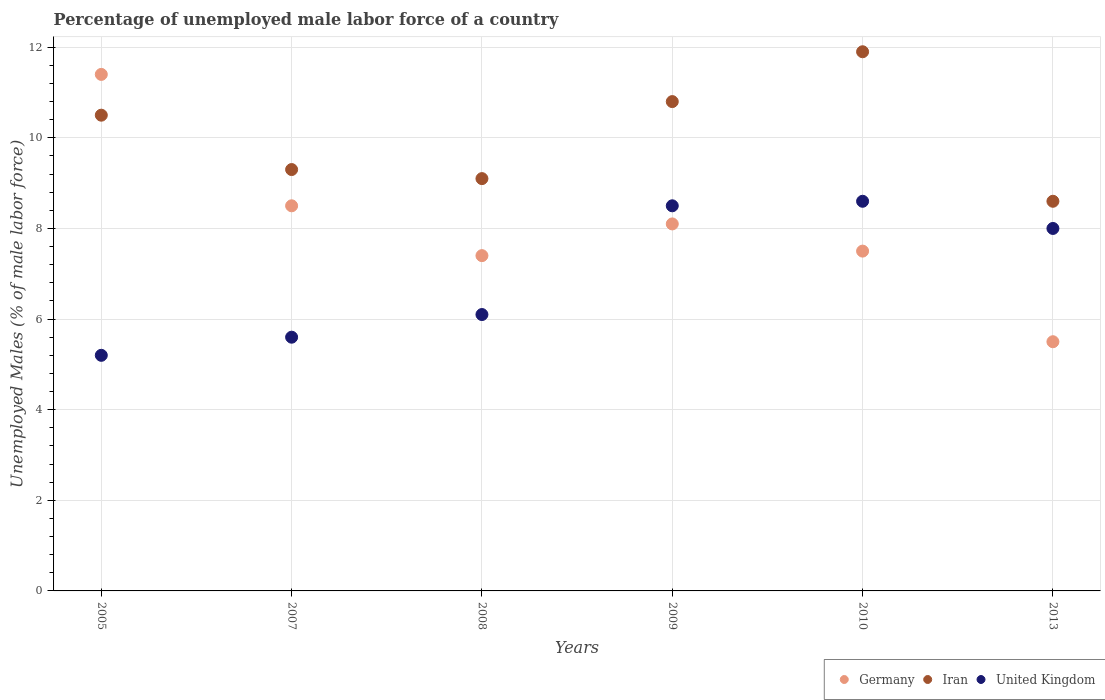Is the number of dotlines equal to the number of legend labels?
Give a very brief answer. Yes. What is the percentage of unemployed male labor force in Iran in 2010?
Make the answer very short. 11.9. Across all years, what is the maximum percentage of unemployed male labor force in Germany?
Your answer should be compact. 11.4. What is the total percentage of unemployed male labor force in Germany in the graph?
Your response must be concise. 48.4. What is the difference between the percentage of unemployed male labor force in United Kingdom in 2005 and that in 2010?
Ensure brevity in your answer.  -3.4. What is the difference between the percentage of unemployed male labor force in Iran in 2005 and the percentage of unemployed male labor force in Germany in 2009?
Keep it short and to the point. 2.4. What is the average percentage of unemployed male labor force in United Kingdom per year?
Give a very brief answer. 7. In the year 2005, what is the difference between the percentage of unemployed male labor force in United Kingdom and percentage of unemployed male labor force in Iran?
Make the answer very short. -5.3. What is the ratio of the percentage of unemployed male labor force in Iran in 2007 to that in 2008?
Ensure brevity in your answer.  1.02. Is the percentage of unemployed male labor force in Iran in 2005 less than that in 2013?
Offer a terse response. No. Is the difference between the percentage of unemployed male labor force in United Kingdom in 2005 and 2009 greater than the difference between the percentage of unemployed male labor force in Iran in 2005 and 2009?
Your answer should be compact. No. What is the difference between the highest and the second highest percentage of unemployed male labor force in Iran?
Your response must be concise. 1.1. What is the difference between the highest and the lowest percentage of unemployed male labor force in United Kingdom?
Keep it short and to the point. 3.4. Is the sum of the percentage of unemployed male labor force in Iran in 2007 and 2013 greater than the maximum percentage of unemployed male labor force in Germany across all years?
Your answer should be very brief. Yes. Is the percentage of unemployed male labor force in United Kingdom strictly greater than the percentage of unemployed male labor force in Germany over the years?
Make the answer very short. No. Is the percentage of unemployed male labor force in United Kingdom strictly less than the percentage of unemployed male labor force in Iran over the years?
Your answer should be very brief. Yes. How many dotlines are there?
Your answer should be very brief. 3. How many legend labels are there?
Give a very brief answer. 3. What is the title of the graph?
Offer a terse response. Percentage of unemployed male labor force of a country. Does "Korea (Republic)" appear as one of the legend labels in the graph?
Ensure brevity in your answer.  No. What is the label or title of the Y-axis?
Ensure brevity in your answer.  Unemployed Males (% of male labor force). What is the Unemployed Males (% of male labor force) of Germany in 2005?
Your answer should be very brief. 11.4. What is the Unemployed Males (% of male labor force) in Iran in 2005?
Your answer should be compact. 10.5. What is the Unemployed Males (% of male labor force) in United Kingdom in 2005?
Your answer should be compact. 5.2. What is the Unemployed Males (% of male labor force) of Germany in 2007?
Give a very brief answer. 8.5. What is the Unemployed Males (% of male labor force) of Iran in 2007?
Ensure brevity in your answer.  9.3. What is the Unemployed Males (% of male labor force) of United Kingdom in 2007?
Ensure brevity in your answer.  5.6. What is the Unemployed Males (% of male labor force) of Germany in 2008?
Give a very brief answer. 7.4. What is the Unemployed Males (% of male labor force) of Iran in 2008?
Offer a very short reply. 9.1. What is the Unemployed Males (% of male labor force) in United Kingdom in 2008?
Give a very brief answer. 6.1. What is the Unemployed Males (% of male labor force) of Germany in 2009?
Provide a short and direct response. 8.1. What is the Unemployed Males (% of male labor force) in Iran in 2009?
Give a very brief answer. 10.8. What is the Unemployed Males (% of male labor force) in Germany in 2010?
Give a very brief answer. 7.5. What is the Unemployed Males (% of male labor force) of Iran in 2010?
Provide a succinct answer. 11.9. What is the Unemployed Males (% of male labor force) in United Kingdom in 2010?
Provide a short and direct response. 8.6. What is the Unemployed Males (% of male labor force) in Germany in 2013?
Provide a short and direct response. 5.5. What is the Unemployed Males (% of male labor force) of Iran in 2013?
Your answer should be very brief. 8.6. What is the Unemployed Males (% of male labor force) in United Kingdom in 2013?
Your answer should be compact. 8. Across all years, what is the maximum Unemployed Males (% of male labor force) in Germany?
Your response must be concise. 11.4. Across all years, what is the maximum Unemployed Males (% of male labor force) of Iran?
Offer a very short reply. 11.9. Across all years, what is the maximum Unemployed Males (% of male labor force) of United Kingdom?
Ensure brevity in your answer.  8.6. Across all years, what is the minimum Unemployed Males (% of male labor force) of Germany?
Offer a very short reply. 5.5. Across all years, what is the minimum Unemployed Males (% of male labor force) in Iran?
Provide a short and direct response. 8.6. Across all years, what is the minimum Unemployed Males (% of male labor force) in United Kingdom?
Ensure brevity in your answer.  5.2. What is the total Unemployed Males (% of male labor force) in Germany in the graph?
Your response must be concise. 48.4. What is the total Unemployed Males (% of male labor force) of Iran in the graph?
Provide a succinct answer. 60.2. What is the total Unemployed Males (% of male labor force) in United Kingdom in the graph?
Provide a short and direct response. 42. What is the difference between the Unemployed Males (% of male labor force) of Germany in 2005 and that in 2007?
Offer a very short reply. 2.9. What is the difference between the Unemployed Males (% of male labor force) of Iran in 2005 and that in 2007?
Keep it short and to the point. 1.2. What is the difference between the Unemployed Males (% of male labor force) in United Kingdom in 2005 and that in 2007?
Your answer should be very brief. -0.4. What is the difference between the Unemployed Males (% of male labor force) of United Kingdom in 2005 and that in 2008?
Offer a very short reply. -0.9. What is the difference between the Unemployed Males (% of male labor force) in Iran in 2005 and that in 2009?
Offer a very short reply. -0.3. What is the difference between the Unemployed Males (% of male labor force) in Iran in 2005 and that in 2010?
Provide a succinct answer. -1.4. What is the difference between the Unemployed Males (% of male labor force) in Germany in 2005 and that in 2013?
Your answer should be compact. 5.9. What is the difference between the Unemployed Males (% of male labor force) of Iran in 2007 and that in 2008?
Your response must be concise. 0.2. What is the difference between the Unemployed Males (% of male labor force) in Germany in 2007 and that in 2009?
Keep it short and to the point. 0.4. What is the difference between the Unemployed Males (% of male labor force) in Iran in 2007 and that in 2009?
Make the answer very short. -1.5. What is the difference between the Unemployed Males (% of male labor force) in United Kingdom in 2007 and that in 2010?
Your response must be concise. -3. What is the difference between the Unemployed Males (% of male labor force) in Iran in 2007 and that in 2013?
Keep it short and to the point. 0.7. What is the difference between the Unemployed Males (% of male labor force) of United Kingdom in 2007 and that in 2013?
Your response must be concise. -2.4. What is the difference between the Unemployed Males (% of male labor force) in Germany in 2008 and that in 2009?
Give a very brief answer. -0.7. What is the difference between the Unemployed Males (% of male labor force) in United Kingdom in 2008 and that in 2009?
Keep it short and to the point. -2.4. What is the difference between the Unemployed Males (% of male labor force) of Iran in 2008 and that in 2010?
Provide a succinct answer. -2.8. What is the difference between the Unemployed Males (% of male labor force) in United Kingdom in 2008 and that in 2010?
Your response must be concise. -2.5. What is the difference between the Unemployed Males (% of male labor force) of Germany in 2008 and that in 2013?
Offer a very short reply. 1.9. What is the difference between the Unemployed Males (% of male labor force) in Iran in 2008 and that in 2013?
Provide a succinct answer. 0.5. What is the difference between the Unemployed Males (% of male labor force) of Germany in 2009 and that in 2010?
Offer a terse response. 0.6. What is the difference between the Unemployed Males (% of male labor force) of United Kingdom in 2009 and that in 2010?
Give a very brief answer. -0.1. What is the difference between the Unemployed Males (% of male labor force) of Germany in 2005 and the Unemployed Males (% of male labor force) of United Kingdom in 2007?
Keep it short and to the point. 5.8. What is the difference between the Unemployed Males (% of male labor force) in Iran in 2005 and the Unemployed Males (% of male labor force) in United Kingdom in 2007?
Offer a very short reply. 4.9. What is the difference between the Unemployed Males (% of male labor force) of Germany in 2005 and the Unemployed Males (% of male labor force) of Iran in 2008?
Give a very brief answer. 2.3. What is the difference between the Unemployed Males (% of male labor force) in Germany in 2005 and the Unemployed Males (% of male labor force) in United Kingdom in 2008?
Your response must be concise. 5.3. What is the difference between the Unemployed Males (% of male labor force) of Germany in 2005 and the Unemployed Males (% of male labor force) of United Kingdom in 2009?
Keep it short and to the point. 2.9. What is the difference between the Unemployed Males (% of male labor force) of Iran in 2005 and the Unemployed Males (% of male labor force) of United Kingdom in 2009?
Your answer should be compact. 2. What is the difference between the Unemployed Males (% of male labor force) of Germany in 2005 and the Unemployed Males (% of male labor force) of Iran in 2010?
Offer a very short reply. -0.5. What is the difference between the Unemployed Males (% of male labor force) of Iran in 2005 and the Unemployed Males (% of male labor force) of United Kingdom in 2013?
Give a very brief answer. 2.5. What is the difference between the Unemployed Males (% of male labor force) of Iran in 2007 and the Unemployed Males (% of male labor force) of United Kingdom in 2008?
Make the answer very short. 3.2. What is the difference between the Unemployed Males (% of male labor force) of Germany in 2007 and the Unemployed Males (% of male labor force) of Iran in 2009?
Keep it short and to the point. -2.3. What is the difference between the Unemployed Males (% of male labor force) in Germany in 2007 and the Unemployed Males (% of male labor force) in United Kingdom in 2009?
Provide a short and direct response. 0. What is the difference between the Unemployed Males (% of male labor force) in Germany in 2007 and the Unemployed Males (% of male labor force) in Iran in 2010?
Your answer should be compact. -3.4. What is the difference between the Unemployed Males (% of male labor force) in Germany in 2007 and the Unemployed Males (% of male labor force) in Iran in 2013?
Your answer should be compact. -0.1. What is the difference between the Unemployed Males (% of male labor force) of Germany in 2007 and the Unemployed Males (% of male labor force) of United Kingdom in 2013?
Offer a very short reply. 0.5. What is the difference between the Unemployed Males (% of male labor force) of Iran in 2007 and the Unemployed Males (% of male labor force) of United Kingdom in 2013?
Keep it short and to the point. 1.3. What is the difference between the Unemployed Males (% of male labor force) in Iran in 2008 and the Unemployed Males (% of male labor force) in United Kingdom in 2009?
Give a very brief answer. 0.6. What is the difference between the Unemployed Males (% of male labor force) of Germany in 2008 and the Unemployed Males (% of male labor force) of Iran in 2010?
Make the answer very short. -4.5. What is the difference between the Unemployed Males (% of male labor force) of Germany in 2008 and the Unemployed Males (% of male labor force) of Iran in 2013?
Make the answer very short. -1.2. What is the difference between the Unemployed Males (% of male labor force) in Germany in 2008 and the Unemployed Males (% of male labor force) in United Kingdom in 2013?
Offer a terse response. -0.6. What is the difference between the Unemployed Males (% of male labor force) of Iran in 2008 and the Unemployed Males (% of male labor force) of United Kingdom in 2013?
Offer a very short reply. 1.1. What is the difference between the Unemployed Males (% of male labor force) of Iran in 2009 and the Unemployed Males (% of male labor force) of United Kingdom in 2010?
Offer a very short reply. 2.2. What is the difference between the Unemployed Males (% of male labor force) of Germany in 2009 and the Unemployed Males (% of male labor force) of Iran in 2013?
Provide a succinct answer. -0.5. What is the difference between the Unemployed Males (% of male labor force) of Germany in 2010 and the Unemployed Males (% of male labor force) of Iran in 2013?
Your answer should be very brief. -1.1. What is the difference between the Unemployed Males (% of male labor force) of Germany in 2010 and the Unemployed Males (% of male labor force) of United Kingdom in 2013?
Your response must be concise. -0.5. What is the average Unemployed Males (% of male labor force) in Germany per year?
Offer a terse response. 8.07. What is the average Unemployed Males (% of male labor force) of Iran per year?
Your answer should be compact. 10.03. In the year 2005, what is the difference between the Unemployed Males (% of male labor force) of Germany and Unemployed Males (% of male labor force) of Iran?
Make the answer very short. 0.9. In the year 2005, what is the difference between the Unemployed Males (% of male labor force) of Germany and Unemployed Males (% of male labor force) of United Kingdom?
Keep it short and to the point. 6.2. In the year 2007, what is the difference between the Unemployed Males (% of male labor force) of Iran and Unemployed Males (% of male labor force) of United Kingdom?
Your answer should be very brief. 3.7. In the year 2009, what is the difference between the Unemployed Males (% of male labor force) in Germany and Unemployed Males (% of male labor force) in United Kingdom?
Offer a terse response. -0.4. In the year 2009, what is the difference between the Unemployed Males (% of male labor force) of Iran and Unemployed Males (% of male labor force) of United Kingdom?
Keep it short and to the point. 2.3. In the year 2010, what is the difference between the Unemployed Males (% of male labor force) of Germany and Unemployed Males (% of male labor force) of United Kingdom?
Offer a terse response. -1.1. In the year 2010, what is the difference between the Unemployed Males (% of male labor force) of Iran and Unemployed Males (% of male labor force) of United Kingdom?
Your answer should be very brief. 3.3. What is the ratio of the Unemployed Males (% of male labor force) of Germany in 2005 to that in 2007?
Give a very brief answer. 1.34. What is the ratio of the Unemployed Males (% of male labor force) in Iran in 2005 to that in 2007?
Make the answer very short. 1.13. What is the ratio of the Unemployed Males (% of male labor force) of Germany in 2005 to that in 2008?
Ensure brevity in your answer.  1.54. What is the ratio of the Unemployed Males (% of male labor force) of Iran in 2005 to that in 2008?
Your response must be concise. 1.15. What is the ratio of the Unemployed Males (% of male labor force) of United Kingdom in 2005 to that in 2008?
Ensure brevity in your answer.  0.85. What is the ratio of the Unemployed Males (% of male labor force) in Germany in 2005 to that in 2009?
Your answer should be compact. 1.41. What is the ratio of the Unemployed Males (% of male labor force) in Iran in 2005 to that in 2009?
Give a very brief answer. 0.97. What is the ratio of the Unemployed Males (% of male labor force) of United Kingdom in 2005 to that in 2009?
Give a very brief answer. 0.61. What is the ratio of the Unemployed Males (% of male labor force) in Germany in 2005 to that in 2010?
Provide a short and direct response. 1.52. What is the ratio of the Unemployed Males (% of male labor force) of Iran in 2005 to that in 2010?
Ensure brevity in your answer.  0.88. What is the ratio of the Unemployed Males (% of male labor force) of United Kingdom in 2005 to that in 2010?
Offer a terse response. 0.6. What is the ratio of the Unemployed Males (% of male labor force) of Germany in 2005 to that in 2013?
Offer a terse response. 2.07. What is the ratio of the Unemployed Males (% of male labor force) of Iran in 2005 to that in 2013?
Ensure brevity in your answer.  1.22. What is the ratio of the Unemployed Males (% of male labor force) in United Kingdom in 2005 to that in 2013?
Provide a short and direct response. 0.65. What is the ratio of the Unemployed Males (% of male labor force) in Germany in 2007 to that in 2008?
Offer a terse response. 1.15. What is the ratio of the Unemployed Males (% of male labor force) in Iran in 2007 to that in 2008?
Offer a very short reply. 1.02. What is the ratio of the Unemployed Males (% of male labor force) of United Kingdom in 2007 to that in 2008?
Your response must be concise. 0.92. What is the ratio of the Unemployed Males (% of male labor force) in Germany in 2007 to that in 2009?
Your answer should be compact. 1.05. What is the ratio of the Unemployed Males (% of male labor force) in Iran in 2007 to that in 2009?
Your response must be concise. 0.86. What is the ratio of the Unemployed Males (% of male labor force) of United Kingdom in 2007 to that in 2009?
Offer a terse response. 0.66. What is the ratio of the Unemployed Males (% of male labor force) of Germany in 2007 to that in 2010?
Offer a very short reply. 1.13. What is the ratio of the Unemployed Males (% of male labor force) of Iran in 2007 to that in 2010?
Ensure brevity in your answer.  0.78. What is the ratio of the Unemployed Males (% of male labor force) in United Kingdom in 2007 to that in 2010?
Provide a succinct answer. 0.65. What is the ratio of the Unemployed Males (% of male labor force) of Germany in 2007 to that in 2013?
Offer a terse response. 1.55. What is the ratio of the Unemployed Males (% of male labor force) in Iran in 2007 to that in 2013?
Your response must be concise. 1.08. What is the ratio of the Unemployed Males (% of male labor force) in Germany in 2008 to that in 2009?
Your response must be concise. 0.91. What is the ratio of the Unemployed Males (% of male labor force) in Iran in 2008 to that in 2009?
Offer a very short reply. 0.84. What is the ratio of the Unemployed Males (% of male labor force) in United Kingdom in 2008 to that in 2009?
Provide a succinct answer. 0.72. What is the ratio of the Unemployed Males (% of male labor force) in Germany in 2008 to that in 2010?
Make the answer very short. 0.99. What is the ratio of the Unemployed Males (% of male labor force) in Iran in 2008 to that in 2010?
Provide a short and direct response. 0.76. What is the ratio of the Unemployed Males (% of male labor force) in United Kingdom in 2008 to that in 2010?
Keep it short and to the point. 0.71. What is the ratio of the Unemployed Males (% of male labor force) in Germany in 2008 to that in 2013?
Your response must be concise. 1.35. What is the ratio of the Unemployed Males (% of male labor force) of Iran in 2008 to that in 2013?
Provide a short and direct response. 1.06. What is the ratio of the Unemployed Males (% of male labor force) in United Kingdom in 2008 to that in 2013?
Your answer should be very brief. 0.76. What is the ratio of the Unemployed Males (% of male labor force) in Iran in 2009 to that in 2010?
Keep it short and to the point. 0.91. What is the ratio of the Unemployed Males (% of male labor force) of United Kingdom in 2009 to that in 2010?
Your answer should be compact. 0.99. What is the ratio of the Unemployed Males (% of male labor force) of Germany in 2009 to that in 2013?
Provide a succinct answer. 1.47. What is the ratio of the Unemployed Males (% of male labor force) in Iran in 2009 to that in 2013?
Offer a very short reply. 1.26. What is the ratio of the Unemployed Males (% of male labor force) in Germany in 2010 to that in 2013?
Make the answer very short. 1.36. What is the ratio of the Unemployed Males (% of male labor force) of Iran in 2010 to that in 2013?
Ensure brevity in your answer.  1.38. What is the ratio of the Unemployed Males (% of male labor force) of United Kingdom in 2010 to that in 2013?
Offer a very short reply. 1.07. What is the difference between the highest and the lowest Unemployed Males (% of male labor force) in Germany?
Make the answer very short. 5.9. 